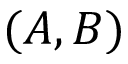<formula> <loc_0><loc_0><loc_500><loc_500>( A , B )</formula> 